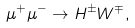Convert formula to latex. <formula><loc_0><loc_0><loc_500><loc_500>\mu ^ { + } \mu ^ { - } \rightarrow H ^ { \pm } W ^ { \mp } ,</formula> 